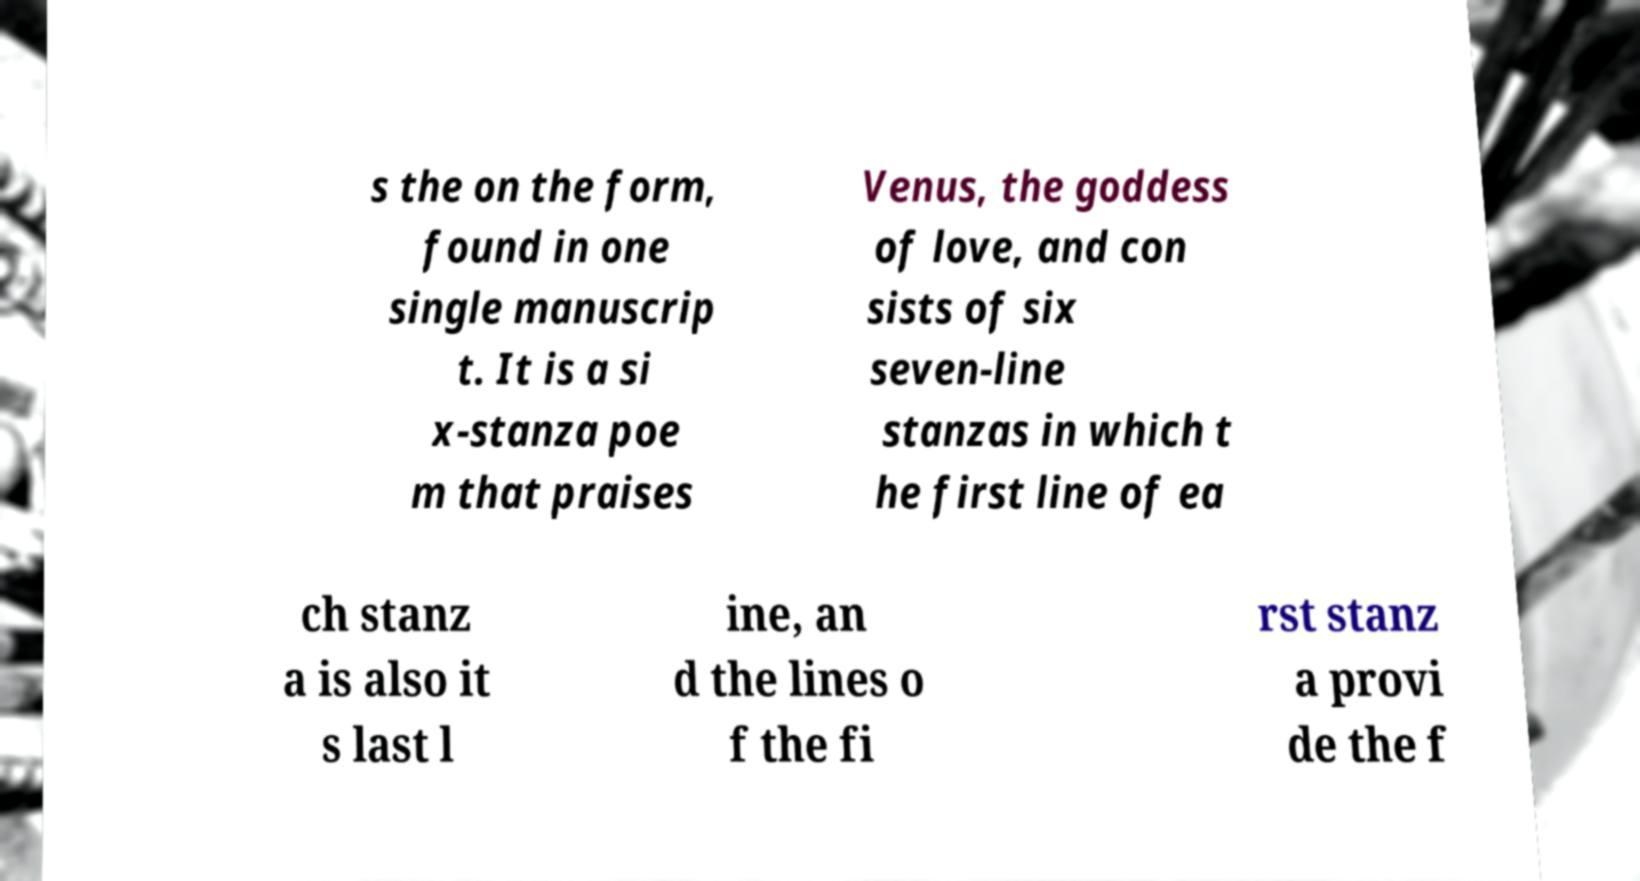Please identify and transcribe the text found in this image. s the on the form, found in one single manuscrip t. It is a si x-stanza poe m that praises Venus, the goddess of love, and con sists of six seven-line stanzas in which t he first line of ea ch stanz a is also it s last l ine, an d the lines o f the fi rst stanz a provi de the f 